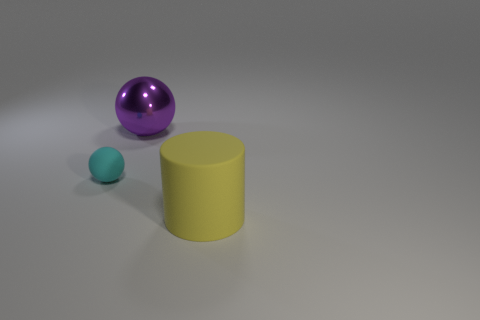There is a cylinder that is the same size as the purple thing; what is its material?
Ensure brevity in your answer.  Rubber. What size is the object behind the cyan sphere?
Your answer should be compact. Large. What is the material of the large yellow cylinder?
Keep it short and to the point. Rubber. What number of things are objects behind the big yellow object or balls on the right side of the tiny object?
Provide a succinct answer. 2. What number of other objects are there of the same color as the big metal thing?
Offer a very short reply. 0. There is a small cyan matte object; does it have the same shape as the large object behind the tiny cyan matte ball?
Offer a terse response. Yes. Are there fewer purple metal spheres that are left of the tiny cyan rubber thing than objects behind the cylinder?
Offer a very short reply. Yes. There is another purple object that is the same shape as the small object; what is its material?
Your answer should be very brief. Metal. Is there anything else that has the same material as the tiny thing?
Make the answer very short. Yes. There is a large yellow thing that is the same material as the cyan thing; what shape is it?
Your response must be concise. Cylinder. 